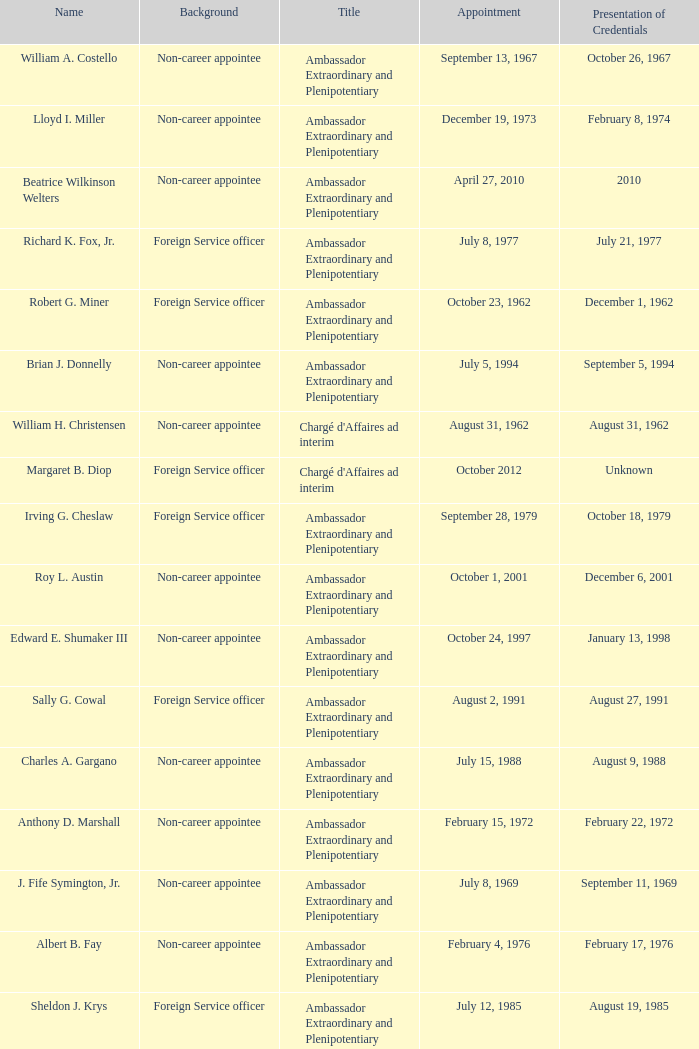What was Anthony D. Marshall's title? Ambassador Extraordinary and Plenipotentiary. 